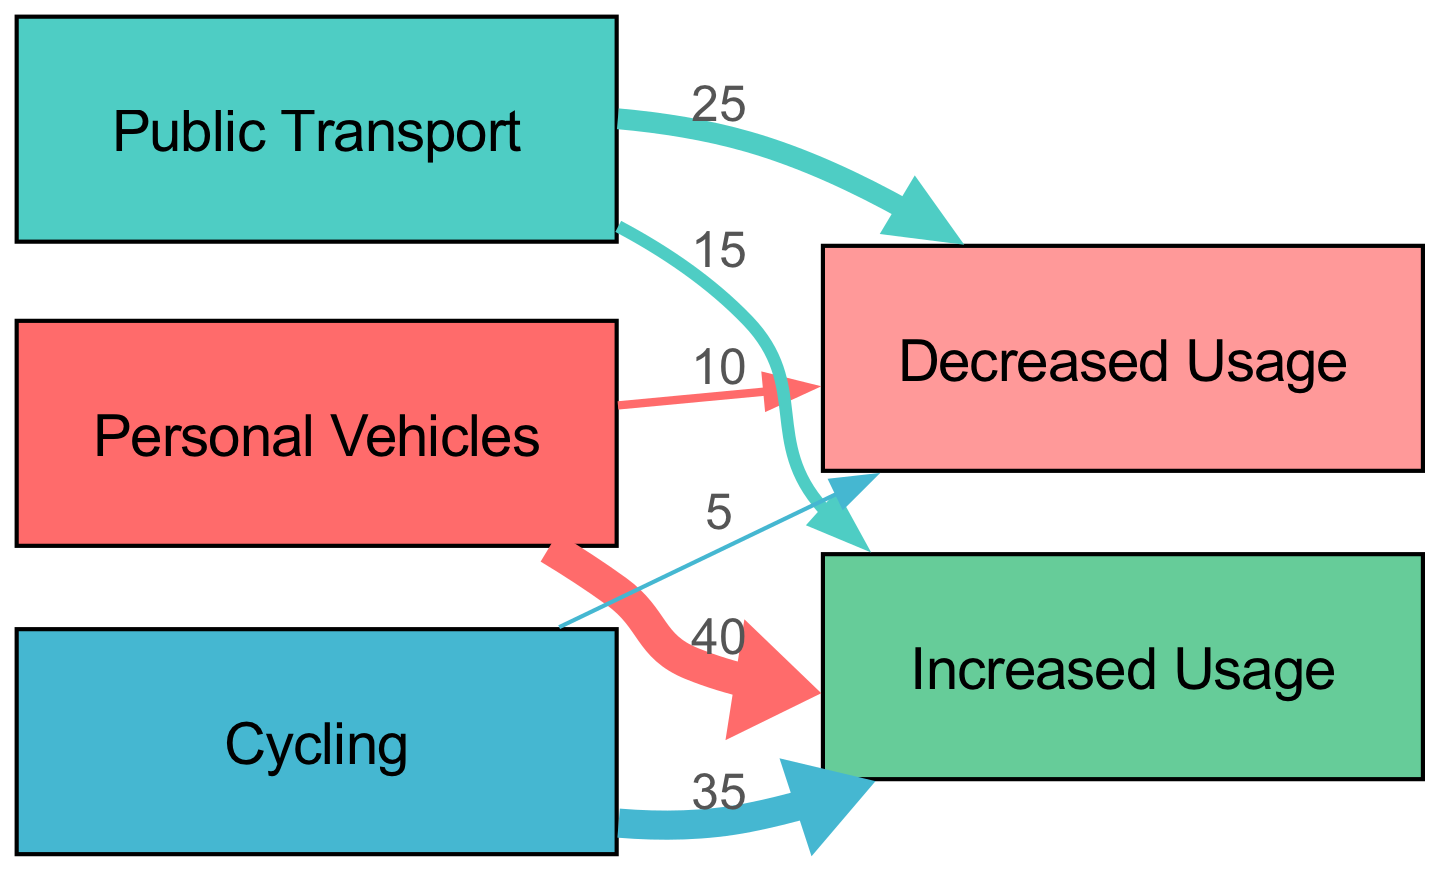What is the total increased usage of personal vehicles? The diagram shows a direct link from "Personal Vehicles" to "Increased Usage" with a value of 40. Thus, the total increased usage of personal vehicles is simply the value on that link.
Answer: 40 How many nodes are there in the diagram? Counting all distinct categories present in the diagram, we have five nodes: "Personal Vehicles", "Public Transport", "Cycling", "Increased Usage", and "Decreased Usage". Adding them gives us five nodes in total.
Answer: 5 What is the total decreased usage for public transport? The link from "Public Transport" to "Decreased Usage" shows a value of 25. This represents the total decreased usage specifically attributed to public transport.
Answer: 25 Which mode of transport has the highest increased usage? Analyzing the values for increased usage, we see "Personal Vehicles" has a value of 40 and "Cycling" has a value of 35. Therefore, "Personal Vehicles" has the highest increased usage among the transport modes listed.
Answer: Personal Vehicles What is the total increased usage from cycling? There are two links from "Cycling": one to "Increased Usage" with a value of 35. Therefore, the total increased usage derived from cycling is simply that value, as it's the only link directed toward increased usage from cycling.
Answer: 35 What is the total decreased usage across all modes of transport? The total decreased usage can be calculated by adding the values of the links leading to "Decreased Usage": 25 from "Public Transport" and 5 from "Cycling", and 10 from "Personal Vehicles". Summing these values gives the total decreased usage as 40.
Answer: 40 Which mode of transport had a decrease in usage? From the diagram, "Public Transport", "Personal Vehicles", and "Cycling" all have links directed towards "Decreased Usage", indicating that these modes experienced a decrease in usage over the past decade.
Answer: Public Transport, Personal Vehicles, Cycling Which mode of transport experienced no net increase in usage? The analysis of the diagram shows that both "Public Transport" and "Cycling" have values indicating increased usage (15 and 35 respectively) and decreased usage as well (25 for public transport and 5 for cycling). However, public transport has a net decrease, having a larger decrease than increase.
Answer: Public Transport 